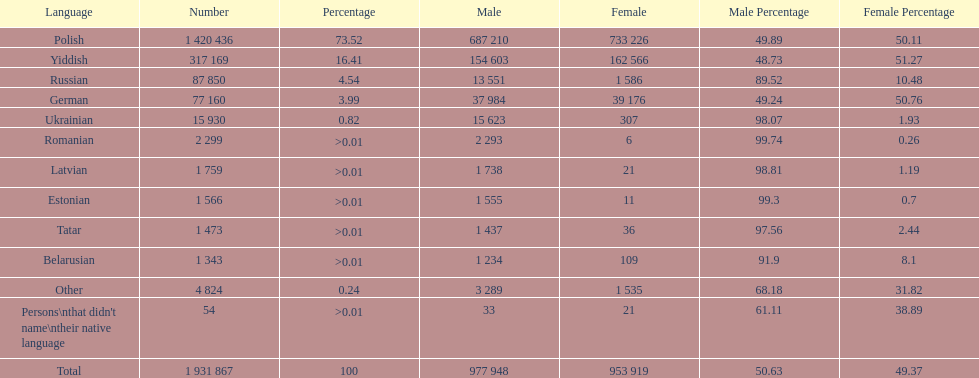Which language had the most number of people speaking it. Polish. 